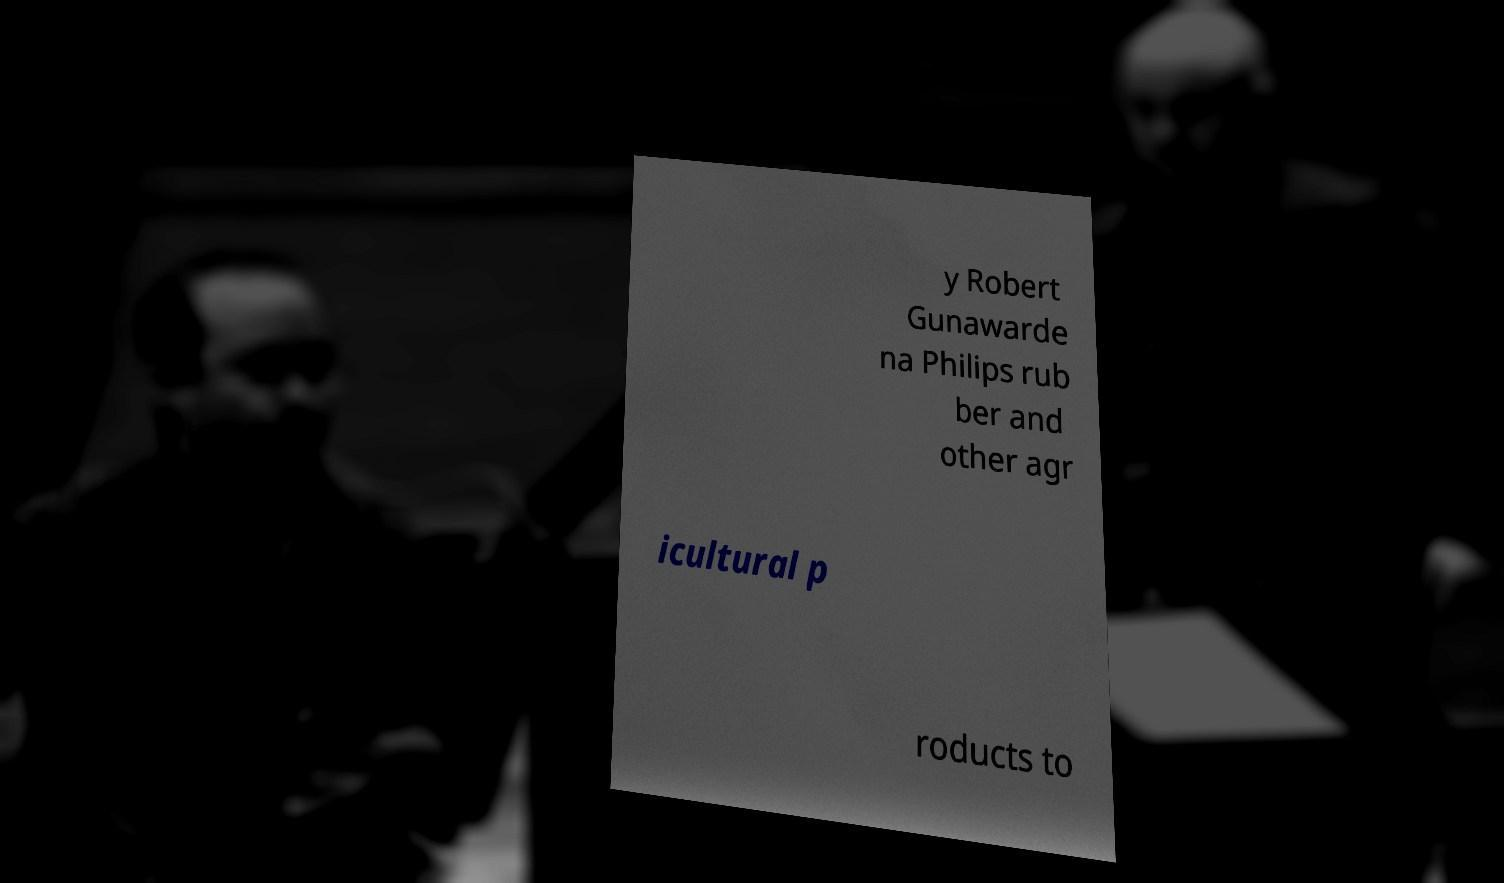I need the written content from this picture converted into text. Can you do that? y Robert Gunawarde na Philips rub ber and other agr icultural p roducts to 